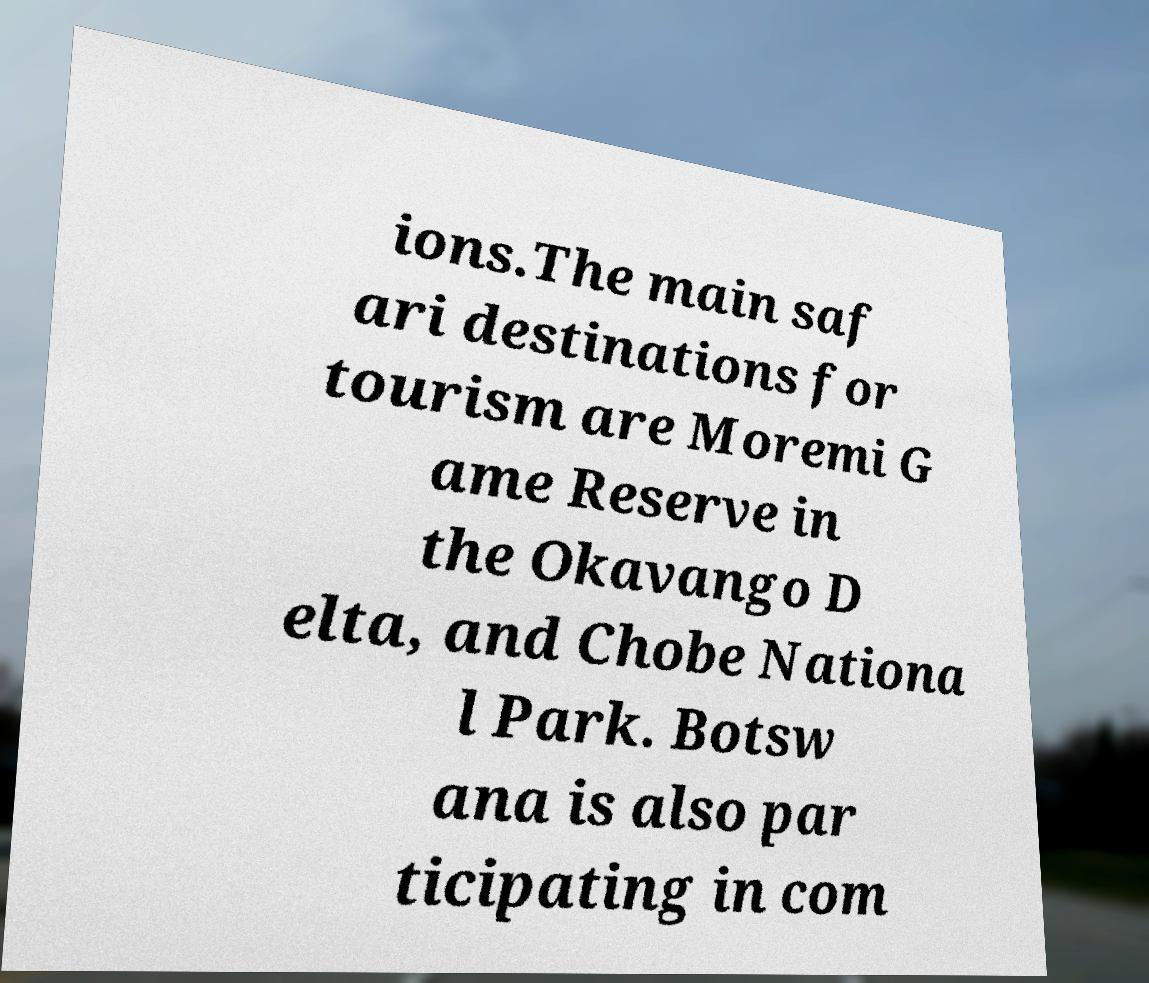Please identify and transcribe the text found in this image. ions.The main saf ari destinations for tourism are Moremi G ame Reserve in the Okavango D elta, and Chobe Nationa l Park. Botsw ana is also par ticipating in com 